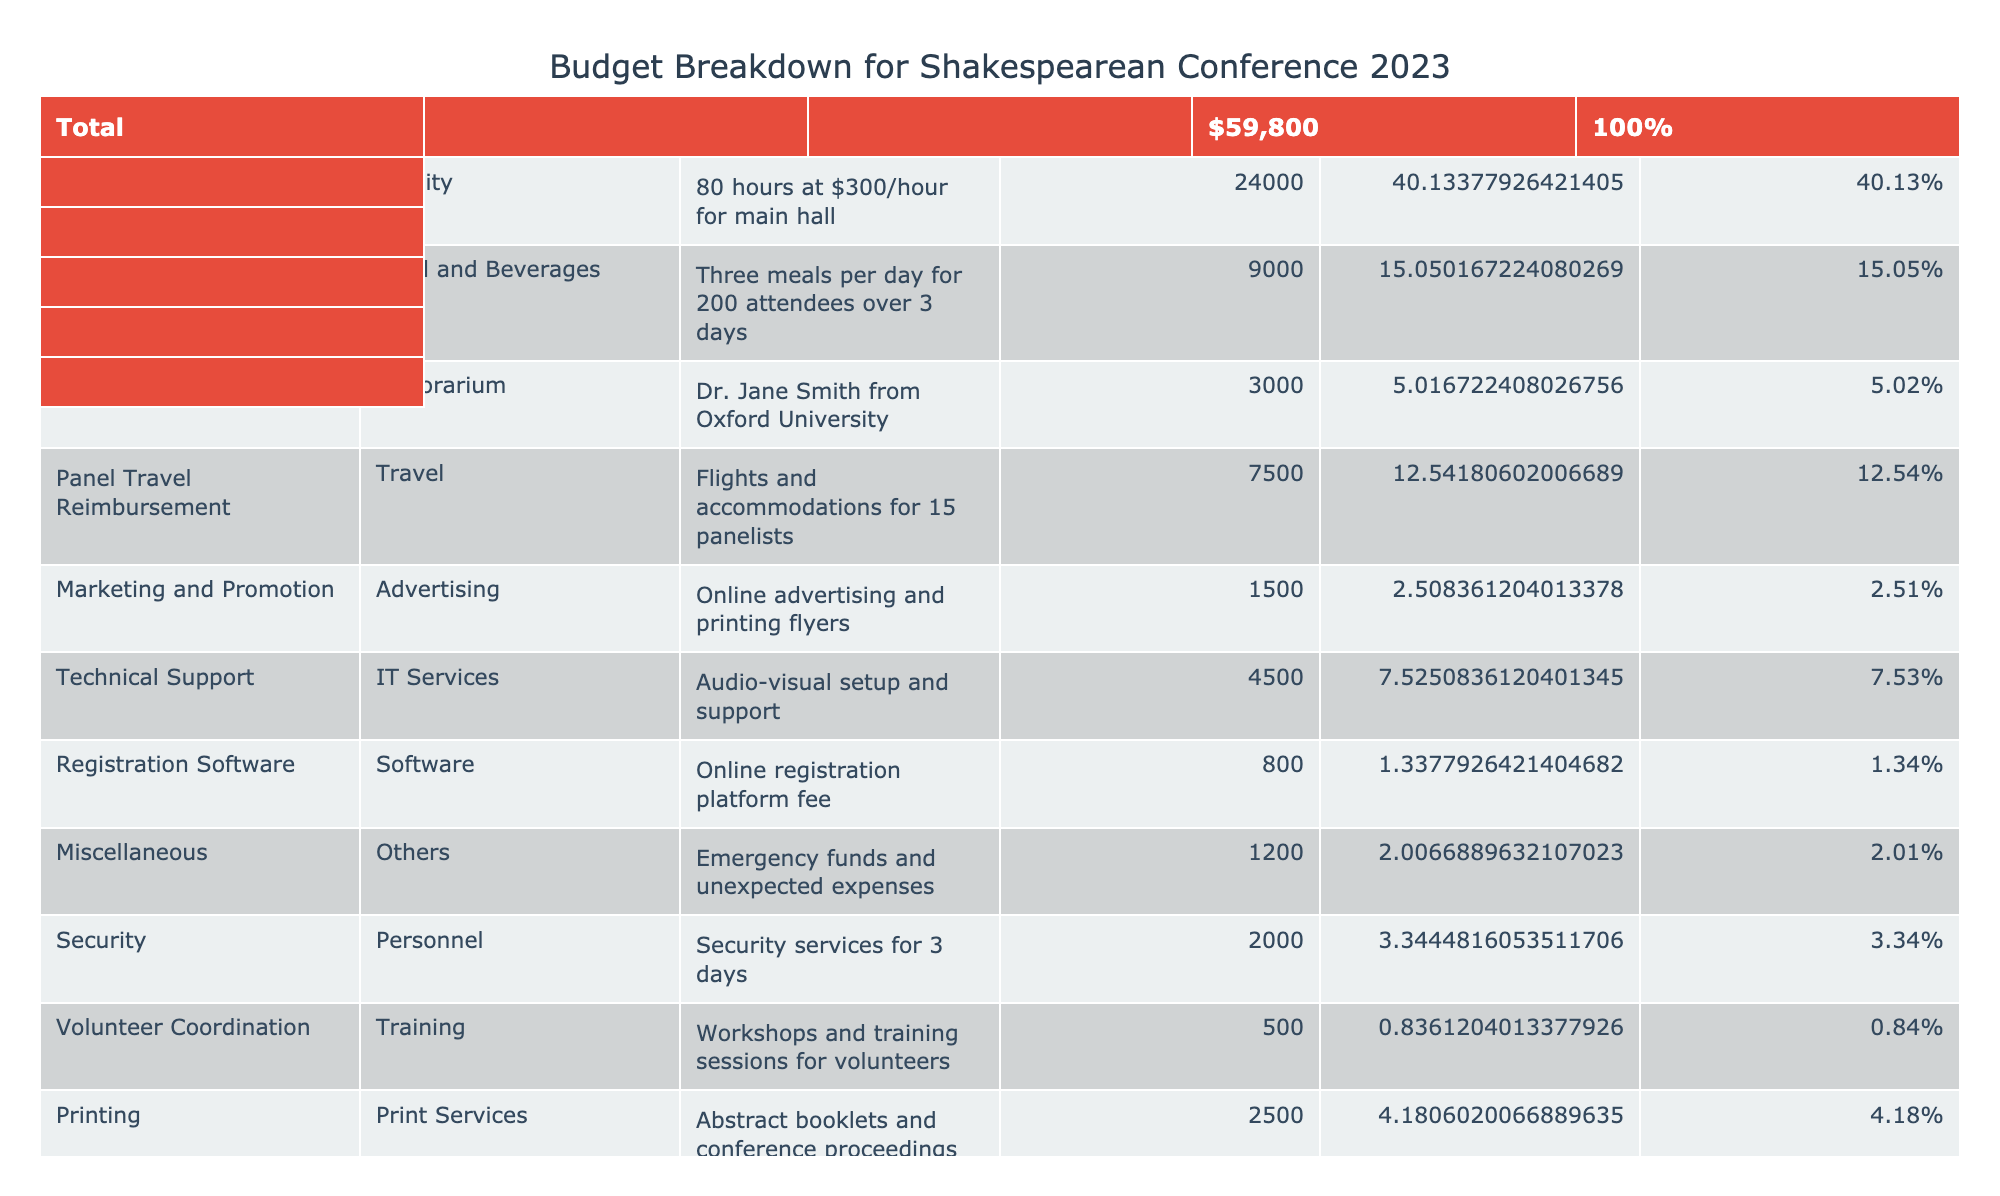What is the total amount allocated for catering? In the table, the row for catering has an amount of $9,000. Therefore, the total amount allocated specifically for catering is just this value.
Answer: 9000 What percentage of the total budget is spent on the venue rental? The total budget is $60,500 (sum of all amounts). The amount for venue rental is $24,000. To find the percentage: (24,000 / 60,500) * 100 = 39.67%.
Answer: 39.67% Does the technical support cost exceed $4,000? The amount listed for technical support is $4,500. Since $4,500 is greater than $4,000, the answer is yes.
Answer: Yes What is the total spent on all personnel-related expenses (security and volunteer coordination)? Security costs $2,000 and volunteer coordination costs $500. Adding these values together gives: 2,000 + 500 = 2,500.
Answer: 2500 What is the average cost of all items in the conference budget? There are 12 items in total. The total budget is $60,500. To find the average cost: 60,500 / 12 = 5,041.67.
Answer: 5041.67 Which item has the highest individual cost and what is that amount? By examining the amounts in the table, the venue rental costs $24,000, which is higher than any other individual item.
Answer: Venue rental, 24000 Is the amount set aside for marketing and promotion more than the amount for printing? Marketing and promotion is allocated $1,500 while printing is allocated $2,500. Since 1,500 is less than 2,500, the answer is no.
Answer: No What is the total budget allocated for travel-related expenses? The travel-related expenses consist of panel travel reimbursement ($7,500) and the transportation cost ($1,800). Adding these together gives: 7,500 + 1,800 = 9,300.
Answer: 9300 If the amount for the keynote speaker fee increases by 10%, what would be the new amount? The current amount for the keynote speaker fee is $3,000. A 10% increase would be calculated as: 3,000 * 0.10 = 300. Therefore, the new amount will be 3,000 + 300 = 3,300.
Answer: 3300 